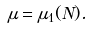Convert formula to latex. <formula><loc_0><loc_0><loc_500><loc_500>\mu = \mu _ { 1 } ( N ) .</formula> 